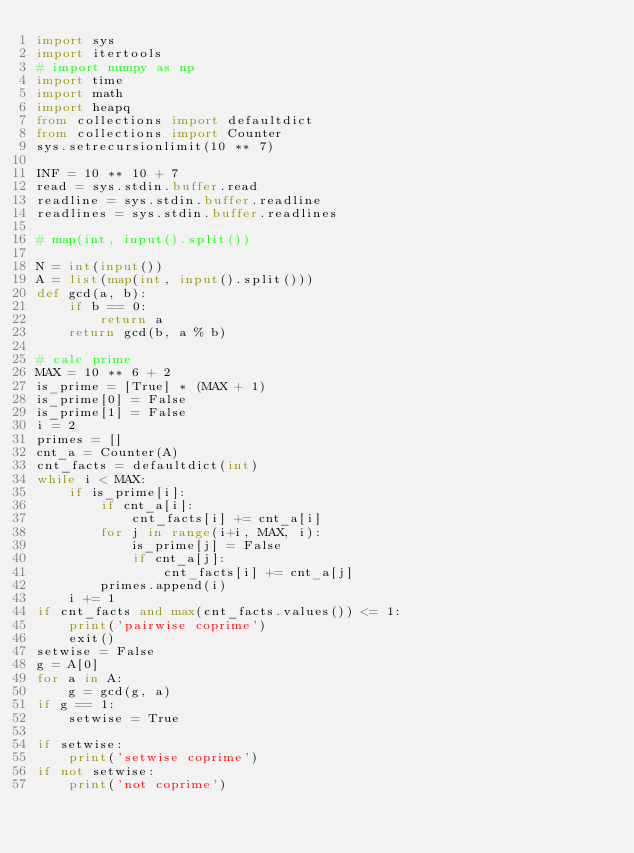<code> <loc_0><loc_0><loc_500><loc_500><_Python_>import sys
import itertools
# import numpy as np
import time
import math
import heapq
from collections import defaultdict
from collections import Counter
sys.setrecursionlimit(10 ** 7)
 
INF = 10 ** 10 + 7
read = sys.stdin.buffer.read
readline = sys.stdin.buffer.readline
readlines = sys.stdin.buffer.readlines

# map(int, input().split())

N = int(input())
A = list(map(int, input().split()))
def gcd(a, b):
    if b == 0:
        return a
    return gcd(b, a % b)

# calc prime
MAX = 10 ** 6 + 2
is_prime = [True] * (MAX + 1)
is_prime[0] = False
is_prime[1] = False
i = 2
primes = []
cnt_a = Counter(A)
cnt_facts = defaultdict(int)
while i < MAX:
    if is_prime[i]:
        if cnt_a[i]:
            cnt_facts[i] += cnt_a[i]
        for j in range(i+i, MAX, i):
            is_prime[j] = False
            if cnt_a[j]:
                cnt_facts[i] += cnt_a[j]
        primes.append(i)
    i += 1
if cnt_facts and max(cnt_facts.values()) <= 1:
    print('pairwise coprime')
    exit()
setwise = False
g = A[0]
for a in A:
    g = gcd(g, a)
if g == 1:
    setwise = True

if setwise:
    print('setwise coprime')
if not setwise:
    print('not coprime')</code> 